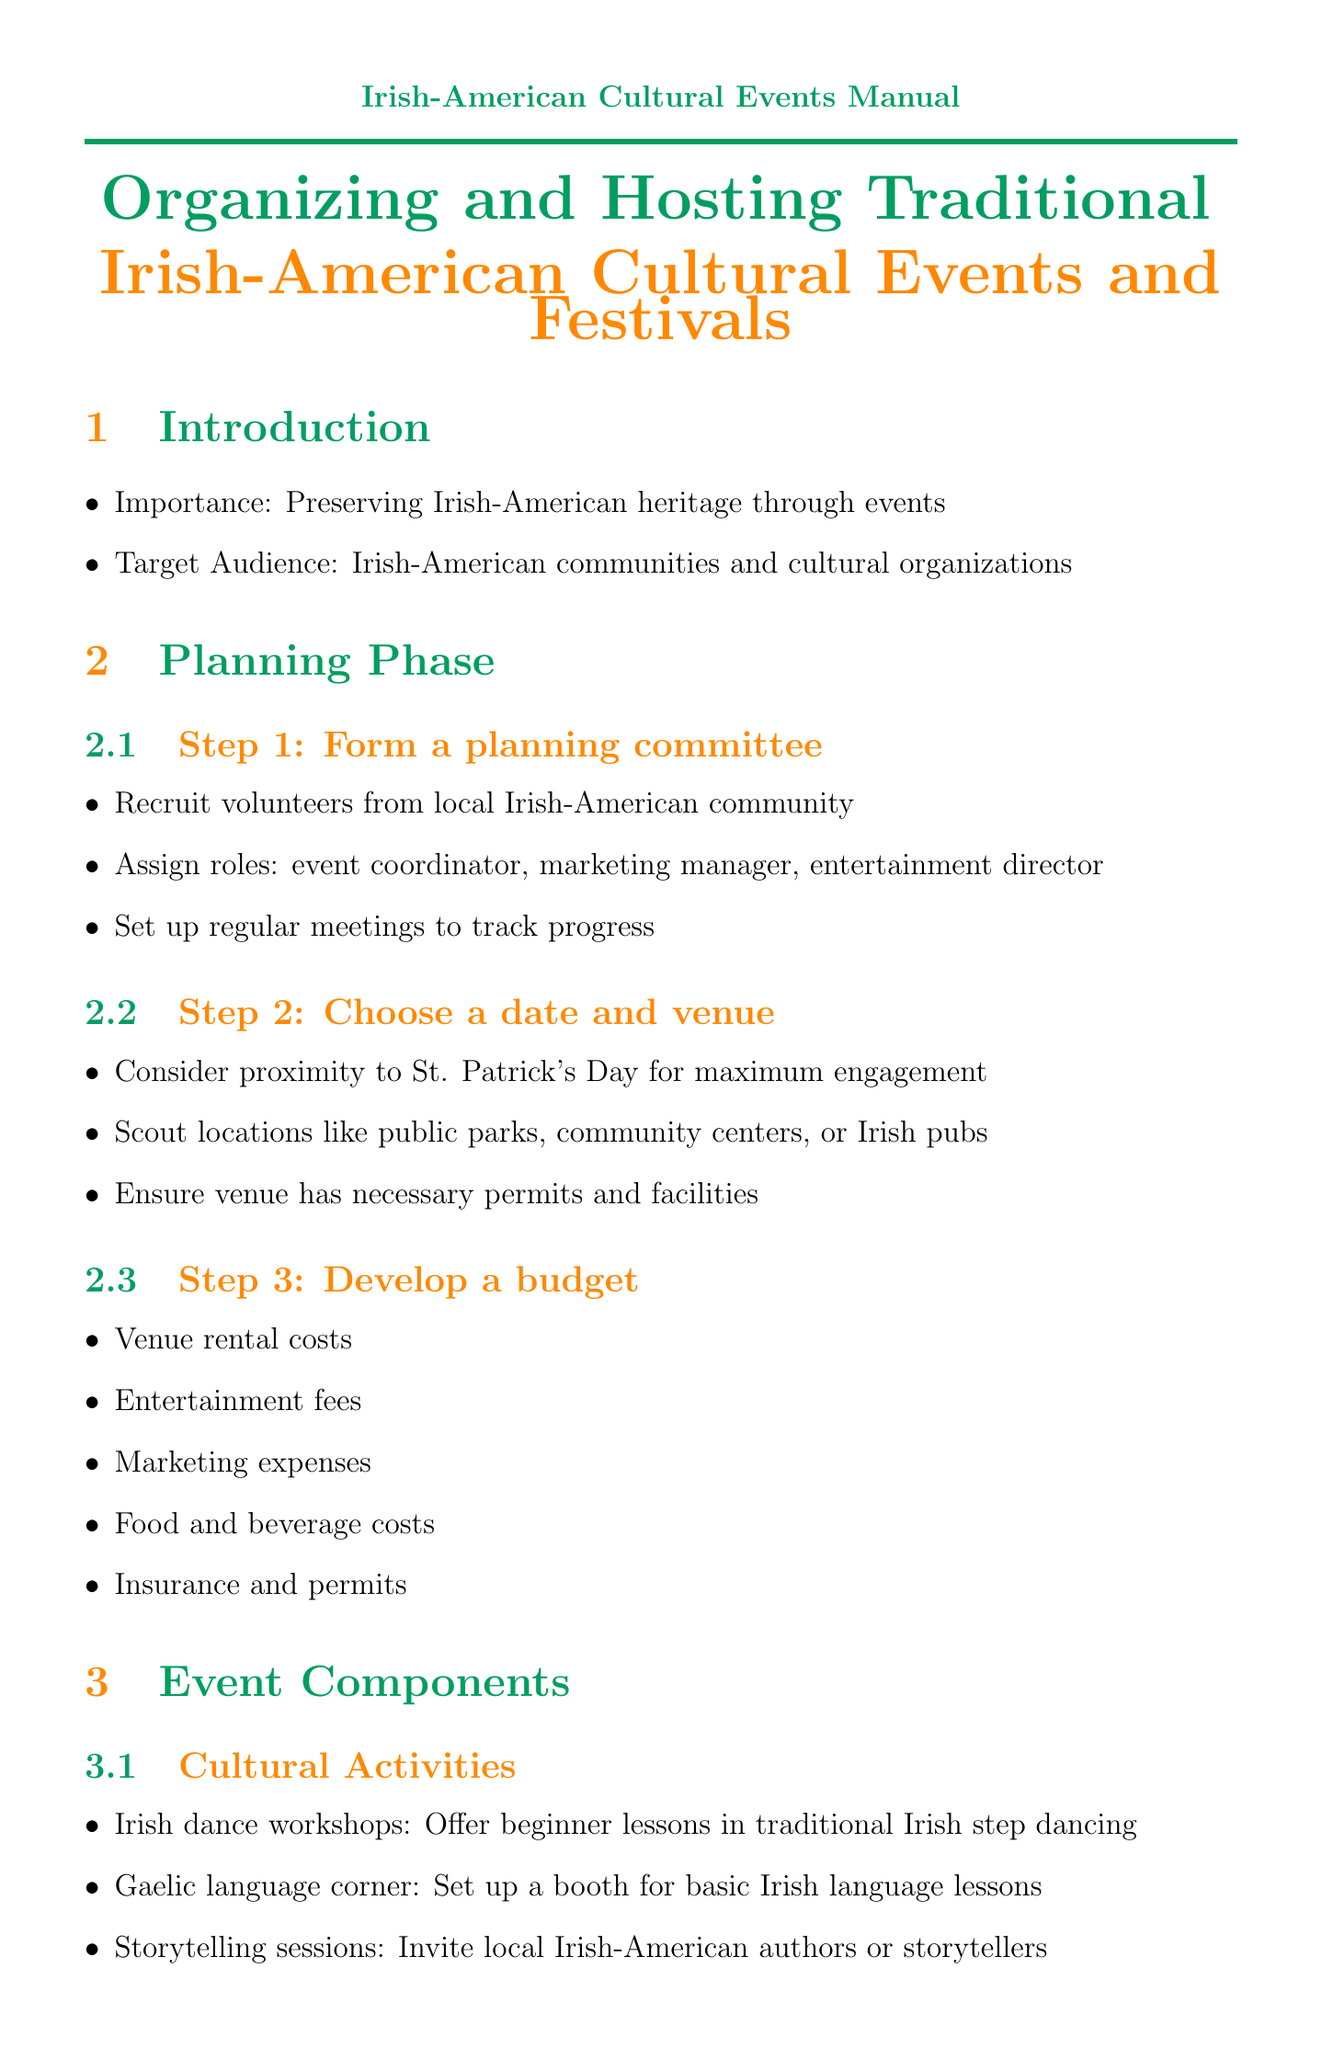what is the title of the document? The title is found at the beginning of the document, which states the focus of the manual.
Answer: Organizing and Hosting Traditional Irish-American Cultural Events and Festivals who should be part of the planning committee? The planning committee should include volunteers from the local Irish-American community, as stated in the document.
Answer: Volunteers what are the three roles assigned in the planning committee? The roles described in the planning phase are critical for organizing the event.
Answer: event coordinator, marketing manager, entertainment director which cultural activity involves beginner lessons? This information highlights a specific activity meant to engage participants.
Answer: Irish dance workshops name one traditional dish mentioned in the document. The document lists various traditional dishes that can be included in the event.
Answer: Shepherd's pie what is one marketing channel suggested in the manual? This reflects the strategies for promoting the event effectively.
Answer: Local Irish-American newspapers what is the last task mentioned in the post-event section? Understanding the last task can provide insight into the planning cycle for events.
Answer: Begin planning for next year's event which organization is suggested for Gaelic language instruction? This shows partnerships that can enhance the cultural aspects of the event.
Answer: Conradh na Gaeilge USA 